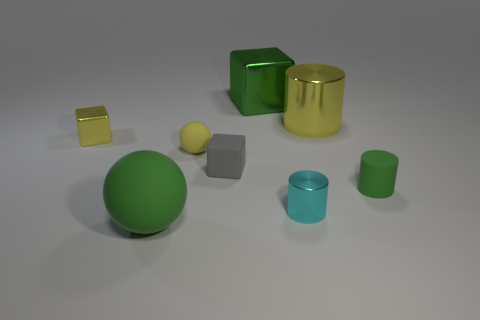There is a cyan cylinder that is the same size as the gray matte block; what is it made of?
Offer a very short reply. Metal. Are there more shiny things than tiny cyan rubber things?
Your answer should be very brief. Yes. There is a ball that is right of the large green thing that is in front of the yellow metallic cube; what is its size?
Give a very brief answer. Small. There is a green metallic object that is the same size as the yellow metal cylinder; what shape is it?
Your answer should be very brief. Cube. What shape is the gray matte object that is in front of the sphere behind the green object that is left of the gray matte cube?
Keep it short and to the point. Cube. Do the rubber sphere in front of the cyan object and the cylinder to the left of the large shiny cylinder have the same color?
Make the answer very short. No. What number of shiny spheres are there?
Your answer should be compact. 0. Are there any yellow shiny things in front of the gray cube?
Ensure brevity in your answer.  No. Does the small object that is to the left of the small ball have the same material as the big green object on the left side of the small gray object?
Ensure brevity in your answer.  No. Is the number of small things that are behind the small shiny cylinder less than the number of small objects?
Make the answer very short. Yes. 